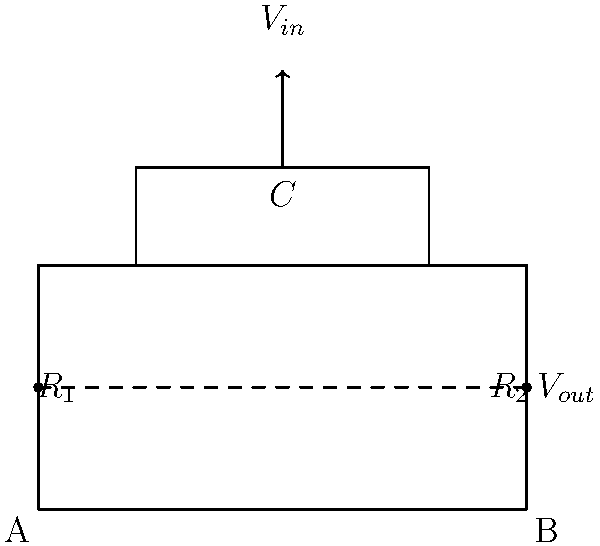In the nanotech-based environmental sensor circuit shown above, $R_1 = 10$ kΩ, $R_2 = 20$ kΩ, and $C = 100$ nF. If the input voltage $V_{in}$ is a sinusoidal signal with a frequency of 1 kHz, what is the cutoff frequency $f_c$ of this low-pass filter in Hz? To find the cutoff frequency of this low-pass RC filter, we need to follow these steps:

1) First, we need to identify the equivalent resistance $R_{eq}$ of the circuit. Since $R_1$ and $R_2$ are in series, we add them:

   $R_{eq} = R_1 + R_2 = 10$ kΩ $+ 20$ kΩ $= 30$ kΩ

2) The cutoff frequency for a low-pass RC filter is given by the formula:

   $f_c = \frac{1}{2\pi RC}$

3) Substituting our values:

   $f_c = \frac{1}{2\pi \cdot 30 \times 10^3 \cdot 100 \times 10^{-9}}$

4) Simplifying:

   $f_c = \frac{1}{2\pi \cdot 30 \times 10^{-6}} = \frac{10^6}{2\pi \cdot 30} \approx 5305.16$ Hz

5) Rounding to the nearest whole number:

   $f_c \approx 5305$ Hz

This cutoff frequency represents the point at which the output signal's amplitude is attenuated by 3 dB compared to the input signal, which is crucial for filtering out high-frequency noise in environmental sensing applications.
Answer: 5305 Hz 